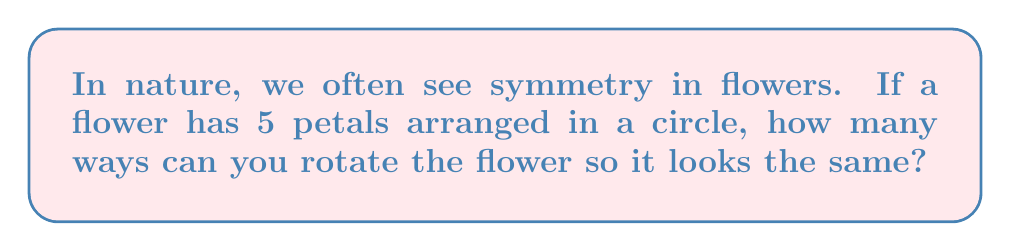Could you help me with this problem? Let's think about this step-by-step:

1. Imagine the flower as a circle with 5 equally spaced points (the petals).

2. We can rotate the flower, and it will look the same if each petal moves to the position of another petal.

3. One full rotation (360°) will make the flower look the same.

4. We can also rotate by smaller amounts:
   - Rotate by 1/5 of a full turn (72°)
   - Rotate by 2/5 of a full turn (144°)
   - Rotate by 3/5 of a full turn (216°)
   - Rotate by 4/5 of a full turn (288°)

5. Each of these rotations, plus not rotating at all (0°), will make the flower look the same.

6. So, we have 5 rotations that make the flower look the same.

In mathematical terms, this flower has 5-fold rotational symmetry, which is related to the concept of cyclic groups in algebra. However, for our non-technical perspective, we can simply think of it as the number of ways we can turn the flower to make it look the same.
Answer: 5 ways 